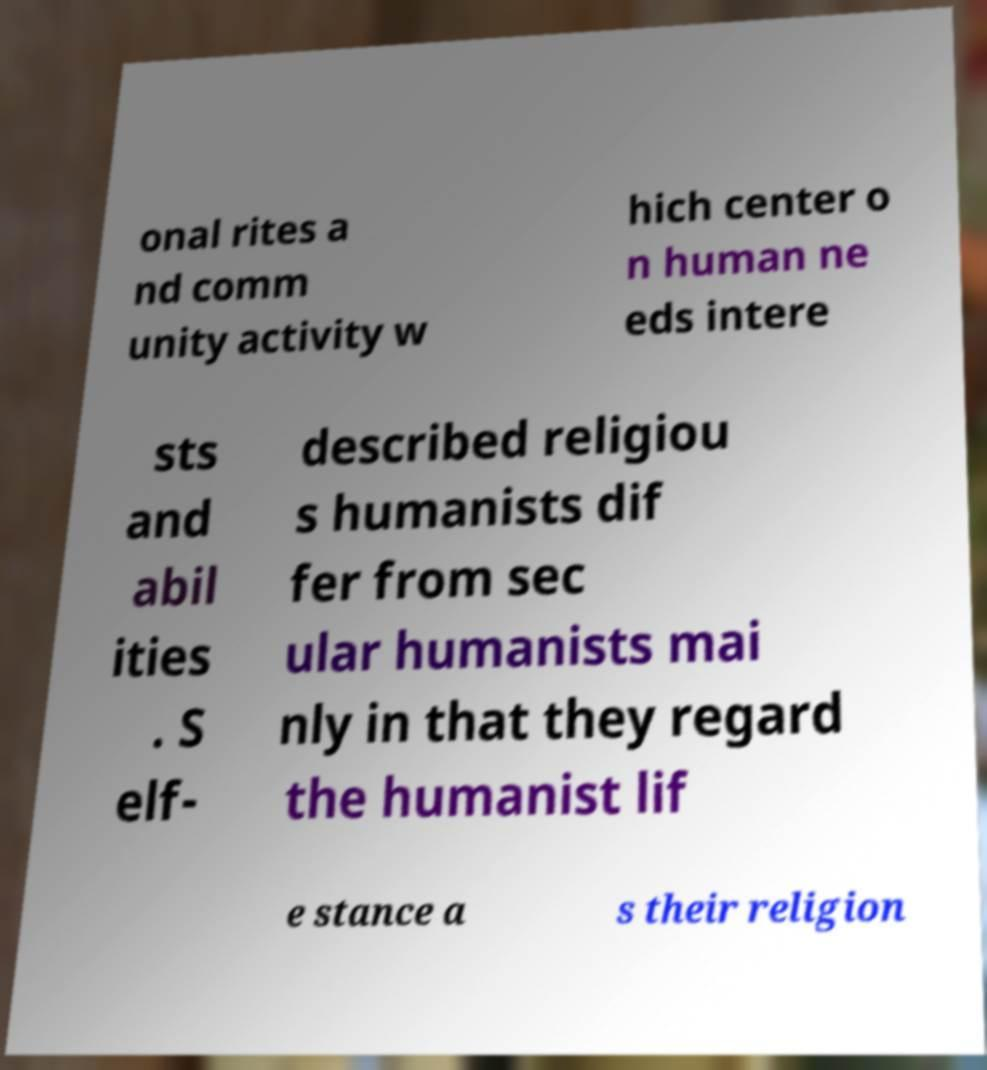Can you accurately transcribe the text from the provided image for me? onal rites a nd comm unity activity w hich center o n human ne eds intere sts and abil ities . S elf- described religiou s humanists dif fer from sec ular humanists mai nly in that they regard the humanist lif e stance a s their religion 